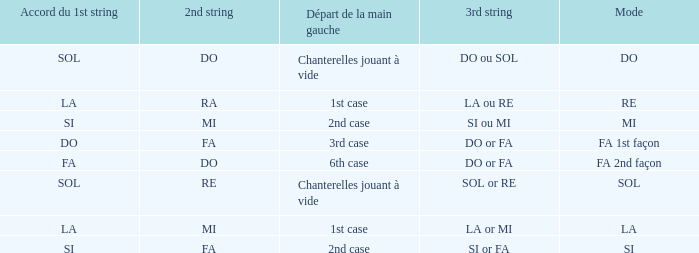For a 1st string of si Accord du and a 2nd string of mi what is the 3rd string? SI ou MI. 